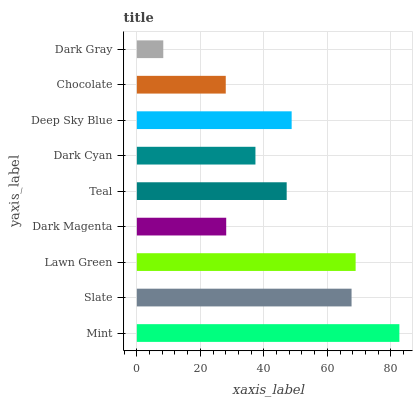Is Dark Gray the minimum?
Answer yes or no. Yes. Is Mint the maximum?
Answer yes or no. Yes. Is Slate the minimum?
Answer yes or no. No. Is Slate the maximum?
Answer yes or no. No. Is Mint greater than Slate?
Answer yes or no. Yes. Is Slate less than Mint?
Answer yes or no. Yes. Is Slate greater than Mint?
Answer yes or no. No. Is Mint less than Slate?
Answer yes or no. No. Is Teal the high median?
Answer yes or no. Yes. Is Teal the low median?
Answer yes or no. Yes. Is Slate the high median?
Answer yes or no. No. Is Dark Magenta the low median?
Answer yes or no. No. 